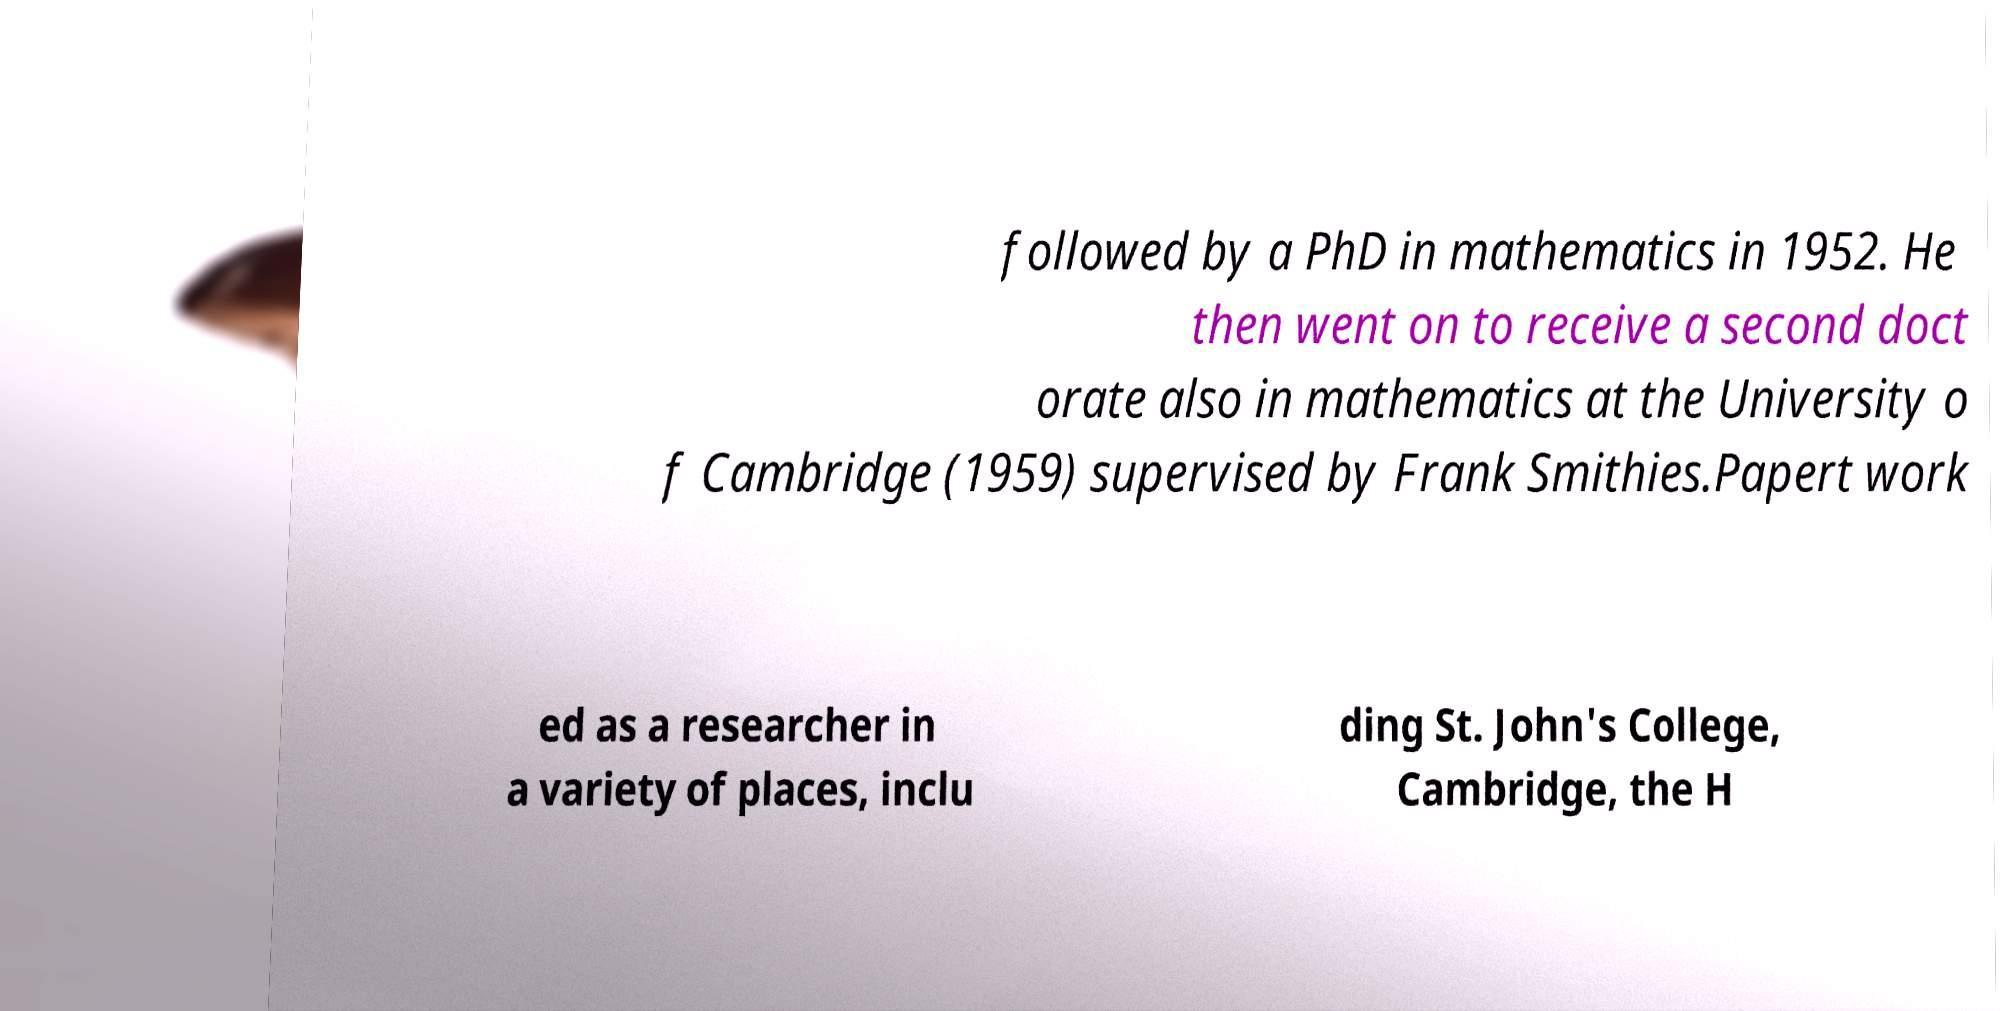I need the written content from this picture converted into text. Can you do that? followed by a PhD in mathematics in 1952. He then went on to receive a second doct orate also in mathematics at the University o f Cambridge (1959) supervised by Frank Smithies.Papert work ed as a researcher in a variety of places, inclu ding St. John's College, Cambridge, the H 